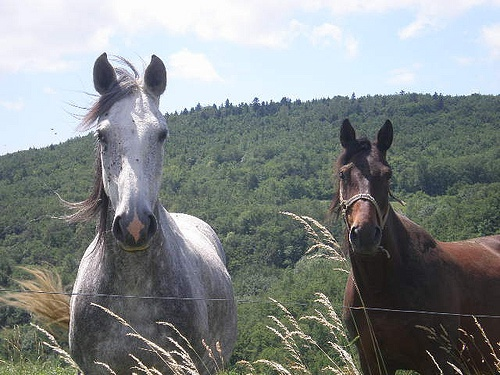Describe the objects in this image and their specific colors. I can see horse in lavender, gray, darkgray, black, and lightgray tones and horse in lavender, black, and gray tones in this image. 